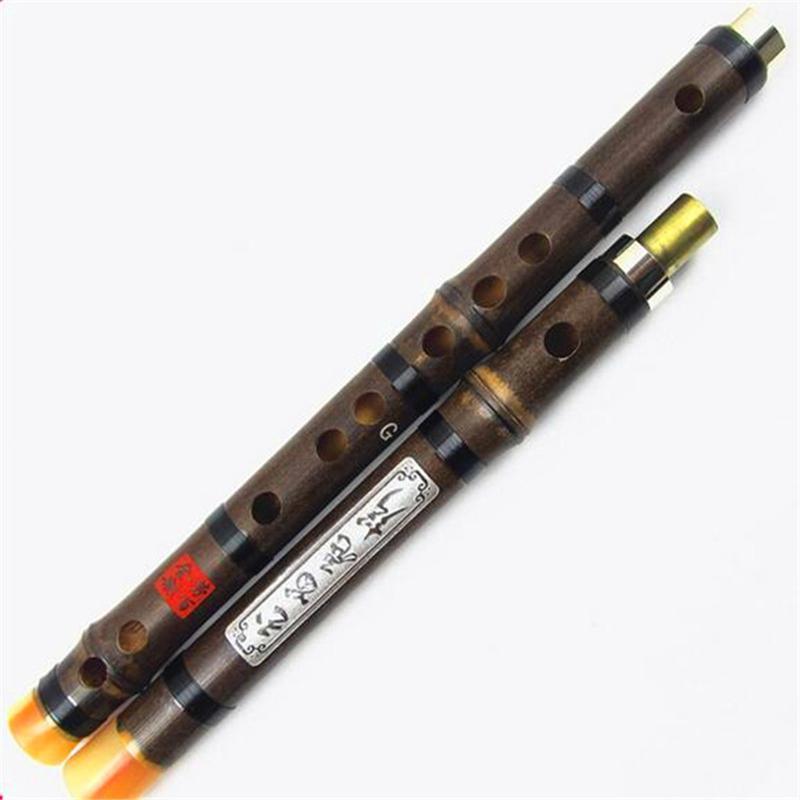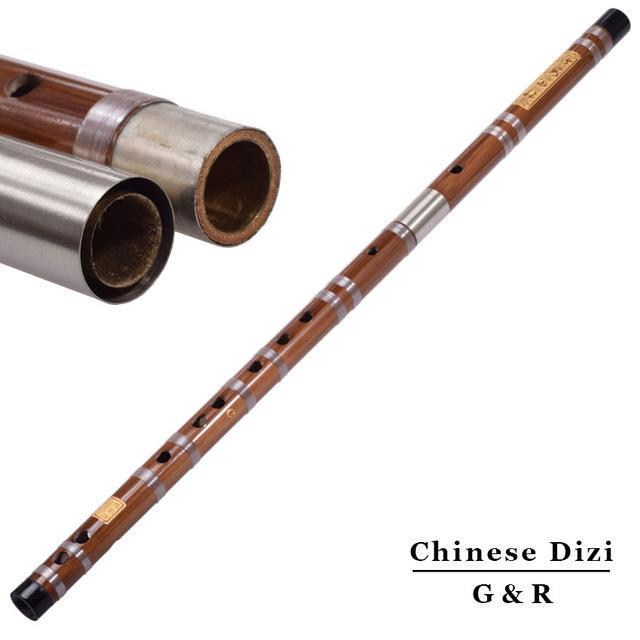The first image is the image on the left, the second image is the image on the right. Evaluate the accuracy of this statement regarding the images: "There is a single flute bar with the left side at the bottom, there are no other pieces in the image.". Is it true? Answer yes or no. No. The first image is the image on the left, the second image is the image on the right. Given the left and right images, does the statement "In the left image, we've got two flute parts parallel to each other." hold true? Answer yes or no. Yes. 